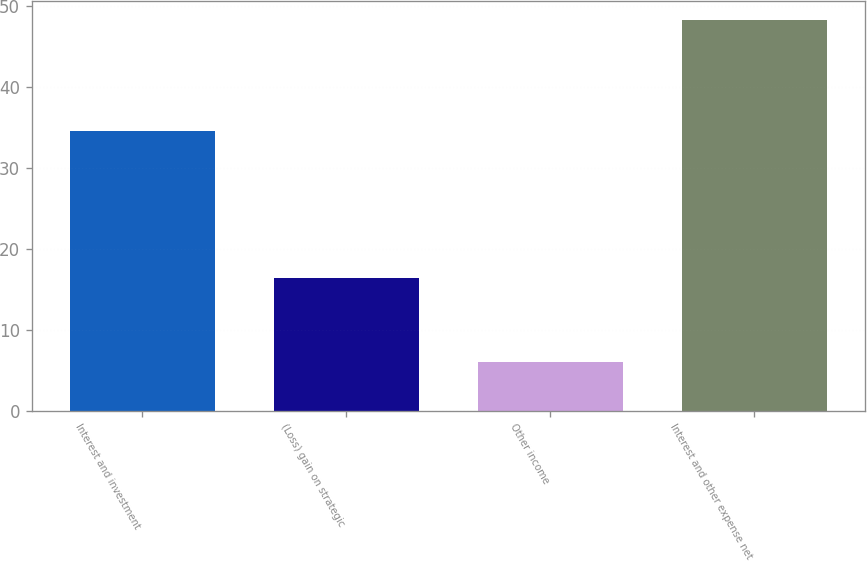<chart> <loc_0><loc_0><loc_500><loc_500><bar_chart><fcel>Interest and investment<fcel>(Loss) gain on strategic<fcel>Other income<fcel>Interest and other expense net<nl><fcel>34.5<fcel>16.4<fcel>6<fcel>48.2<nl></chart> 